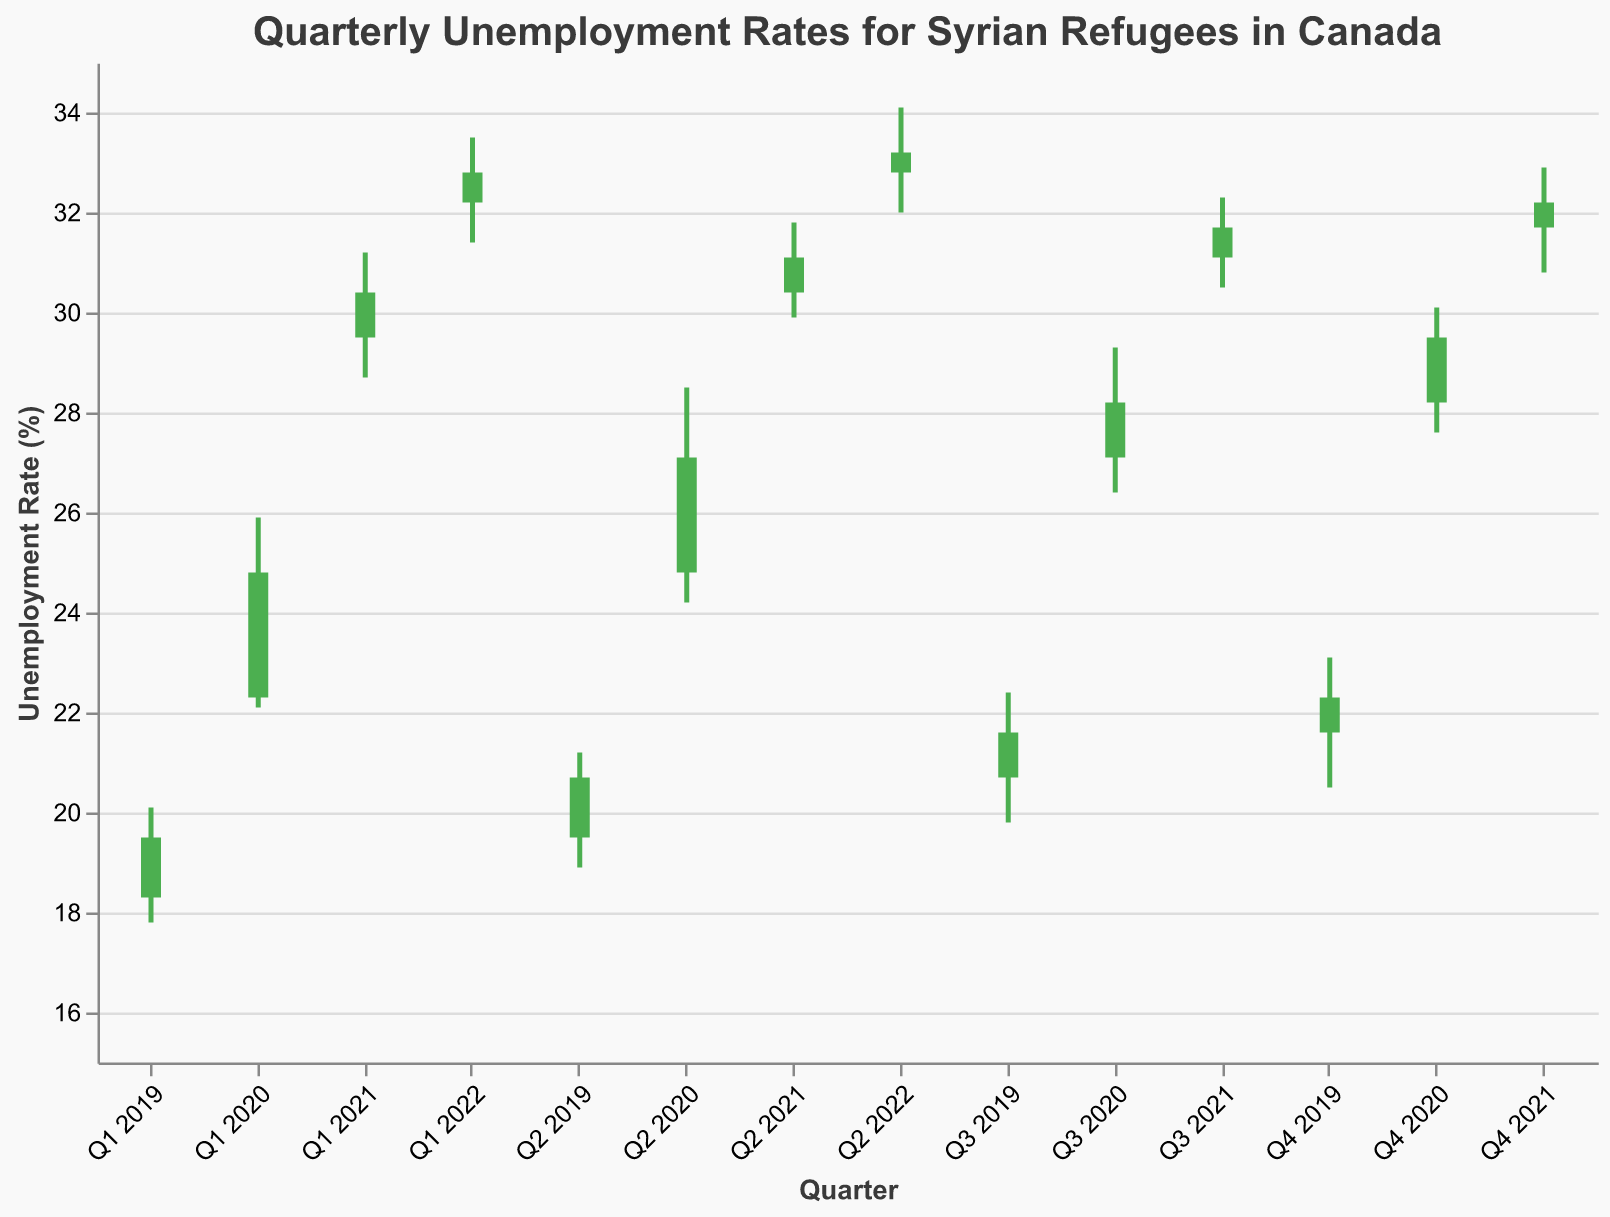What is the title of the chart? The title of the chart is prominently displayed at the top and reads "Quarterly Unemployment Rates for Syrian Refugees in Canada."
Answer: Quarterly Unemployment Rates for Syrian Refugees in Canada During which quarter did the unemployment rate have the highest high value? To determine the quarter with the highest high value, look for the highest point on the High axis. The highest value is 34.1, which occurs in Q2 2022.
Answer: Q2 2022 Which quarter had the lowest unemployment rate value recorded (Low)? By scanning the Low values, we identify the lowest value, which is 17.8, and it occurred in Q1 2019.
Answer: Q1 2019 In which quarter did the unemployment rate show the biggest jump from open to close? (Visual Change) Calculate the difference between the open and close values for all quarters, and identify the largest difference. From Q1 2020's open (22.3) to close (24.8), the change is 2.5, which is the largest visual jump.
Answer: Q1 2020 How did the unemployment rate change from Q1 2019 to Q2 2019 in terms of open and close values? Look at the open and close values for Q1 2019 and Q2 2019. Open in Q1 2019 was 18.3 and close was 19.5. In Q2 2019, open was 19.5 and close was 20.7. The change from Q1 to Q2 is 1.2 for both open and close.
Answer: Increased by 1.2 Which quarters had a higher close value than their open value? Compare the open and close values for each quarter. For quarters where the close is higher than the open: Q1 2019, Q2 2019, Q3 2019, Q4 2019, Q1 2020, Q2 2020, Q3 2020, Q4 2020, Q1 2021, and Q2 2021.
Answer: Q1 2019, Q2 2019, Q3 2019, Q4 2019, Q1 2020, Q2 2020, Q3 2020, Q4 2020, Q1 2021, Q2 2021 Was there any quarter when the unemployment rate closed at the same value as it opened? Assess each quarter to see if the open and close values are identical. No quarters have the same open and close values.
Answer: No What is the average of the high values from Q1 2021 to Q2 2022? Add up the high values from Q1 2021 (31.2), Q2 2021 (31.8), Q3 2021 (32.3), Q4 2021 (32.9), Q1 2022 (33.5), and Q2 2022 (34.1) and divide by the number of quarters, which is (31.2+31.8+32.3+32.9+33.5+34.1)/6 = 32.6333.
Answer: 32.63 Between which quarters was the largest increase in the high values observed? Determine the difference in high values between each consecutive quarter and identify the largest difference. The largest increase is between Q1 2020 (25.9) and Q2 2020 (28.5), with a difference of 2.6.
Answer: Q1 2020 to Q2 2020 